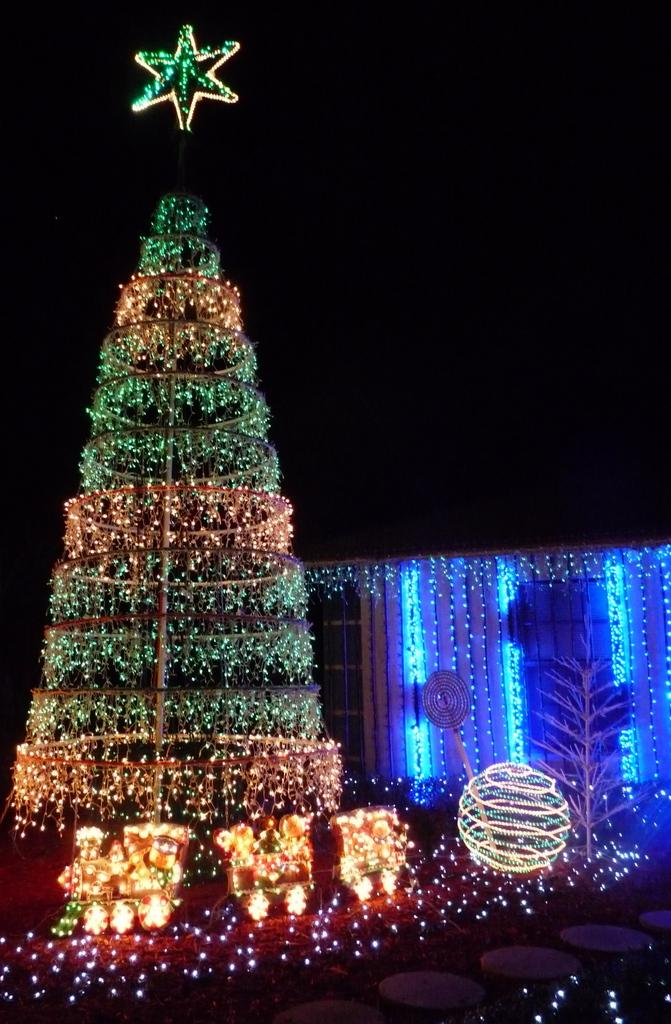What is located on the left side of the image? There is an xmas tree on the left side of the image. How is the xmas tree decorated? The xmas tree is decorated with lights. Are there any decorations at the base of the xmas tree? Yes, there are decorations at the bottom of the xmas tree. What can be seen in the background of the image? There is a building in the background of the image. What type of lunchroom can be seen in the image? There is no lunchroom present in the image; it features an xmas tree and a building in the background. 